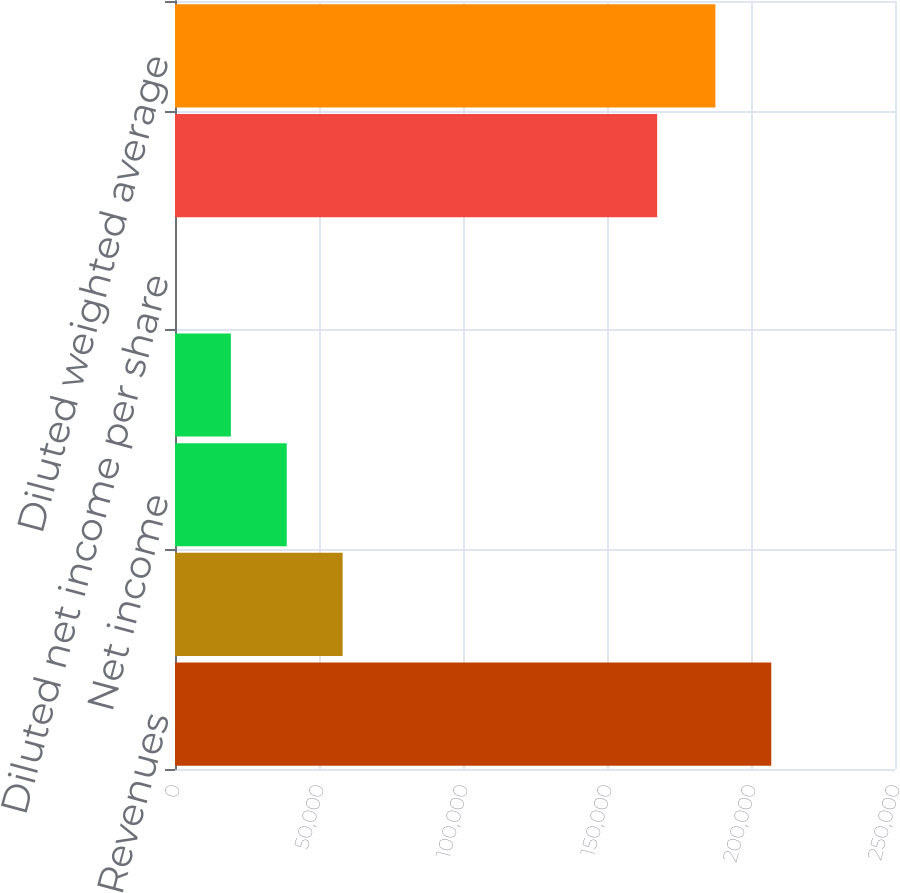Convert chart to OTSL. <chart><loc_0><loc_0><loc_500><loc_500><bar_chart><fcel>Revenues<fcel>Cost of revenues<fcel>Net income<fcel>Basic net income per share<fcel>Diluted net income per share<fcel>Basic weighted average common<fcel>Diluted weighted average<nl><fcel>207041<fcel>58201.3<fcel>38800.9<fcel>19400.6<fcel>0.19<fcel>167417<fcel>187641<nl></chart> 